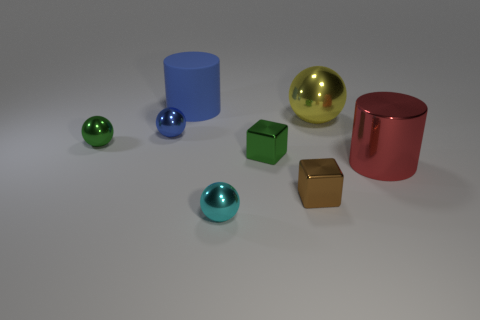Are there any yellow things of the same shape as the small cyan thing?
Your answer should be compact. Yes. What material is the small object that is the same color as the large matte object?
Make the answer very short. Metal. What shape is the green object on the left side of the large blue cylinder?
Provide a succinct answer. Sphere. How many small blue matte blocks are there?
Ensure brevity in your answer.  0. There is a big cylinder that is made of the same material as the large sphere; what color is it?
Provide a succinct answer. Red. What number of small objects are either green metallic balls or cyan things?
Provide a short and direct response. 2. There is a cyan shiny thing; how many yellow objects are in front of it?
Your answer should be very brief. 0. What is the color of the other big thing that is the same shape as the blue metal object?
Your response must be concise. Yellow. What number of matte objects are green spheres or large red cylinders?
Your answer should be very brief. 0. Is there a big object that is behind the large cylinder right of the small cube behind the red cylinder?
Ensure brevity in your answer.  Yes. 